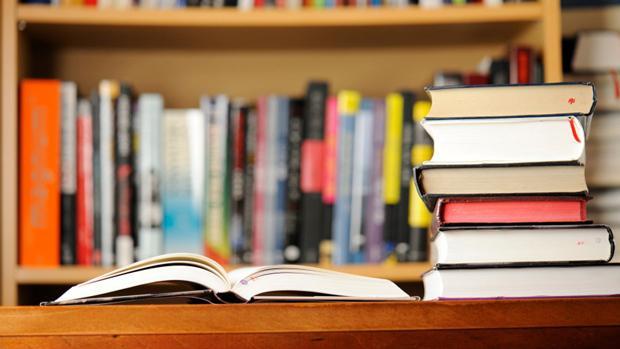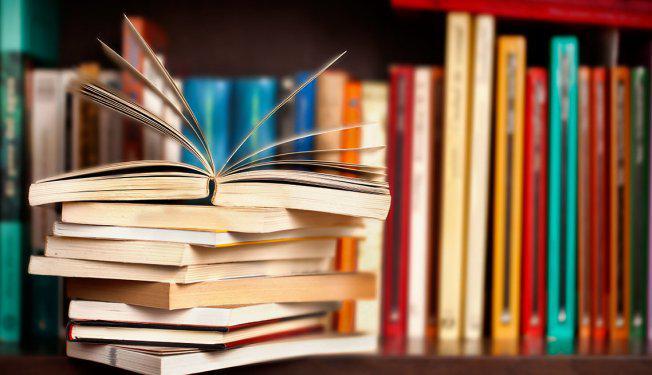The first image is the image on the left, the second image is the image on the right. For the images shown, is this caption "there are open books laying next to a stack of 6 books next to it" true? Answer yes or no. Yes. The first image is the image on the left, the second image is the image on the right. Examine the images to the left and right. Is the description "The right image shows at least one book withe its pages splayed open." accurate? Answer yes or no. Yes. 